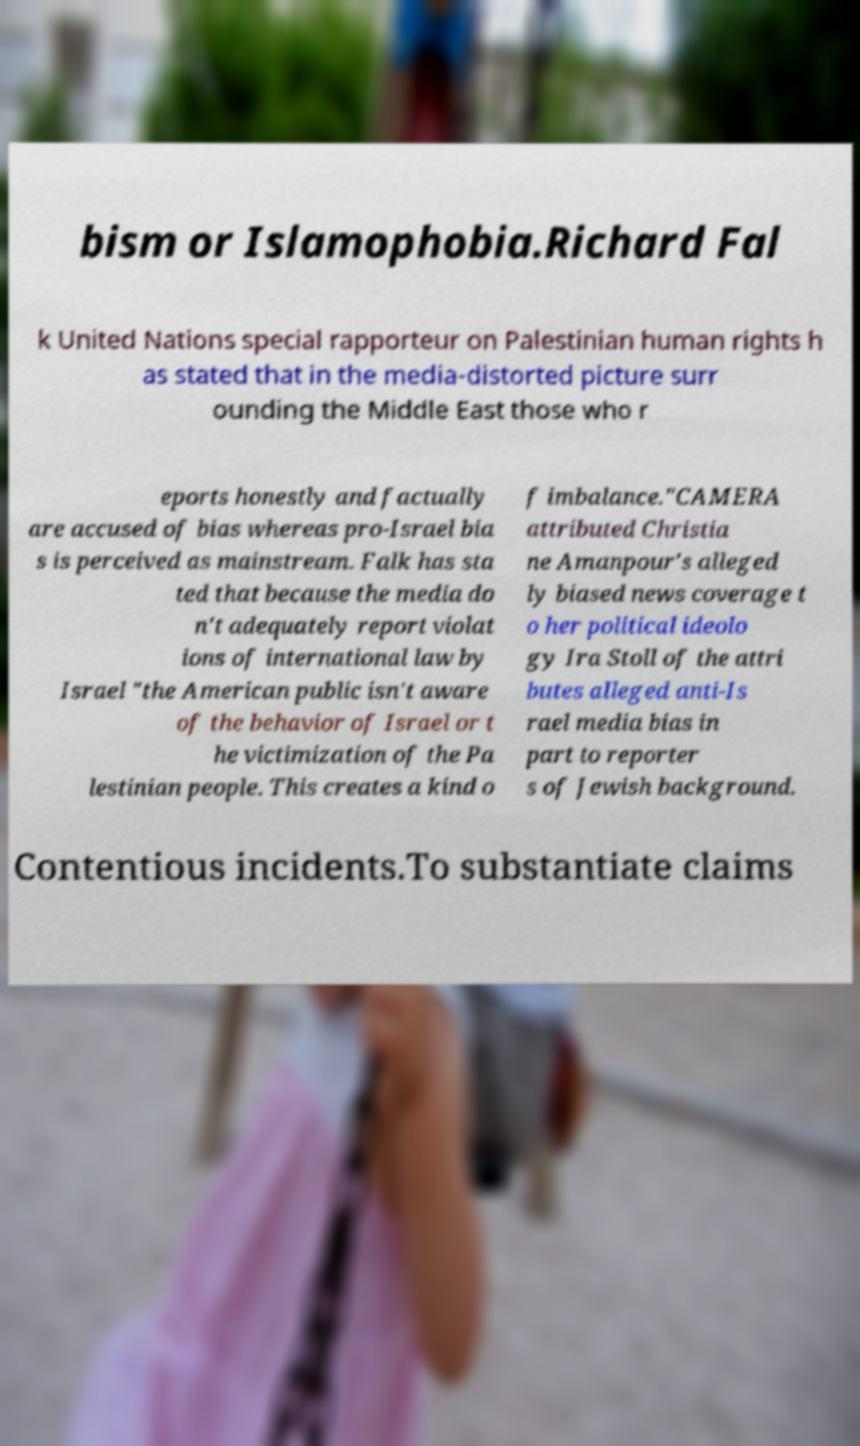Could you assist in decoding the text presented in this image and type it out clearly? bism or Islamophobia.Richard Fal k United Nations special rapporteur on Palestinian human rights h as stated that in the media-distorted picture surr ounding the Middle East those who r eports honestly and factually are accused of bias whereas pro-Israel bia s is perceived as mainstream. Falk has sta ted that because the media do n't adequately report violat ions of international law by Israel "the American public isn't aware of the behavior of Israel or t he victimization of the Pa lestinian people. This creates a kind o f imbalance."CAMERA attributed Christia ne Amanpour's alleged ly biased news coverage t o her political ideolo gy Ira Stoll of the attri butes alleged anti-Is rael media bias in part to reporter s of Jewish background. Contentious incidents.To substantiate claims 